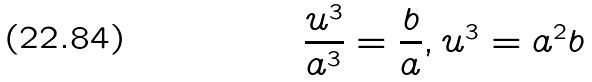Convert formula to latex. <formula><loc_0><loc_0><loc_500><loc_500>\frac { u ^ { 3 } } { a ^ { 3 } } = \frac { b } { a } , u ^ { 3 } = a ^ { 2 } b</formula> 